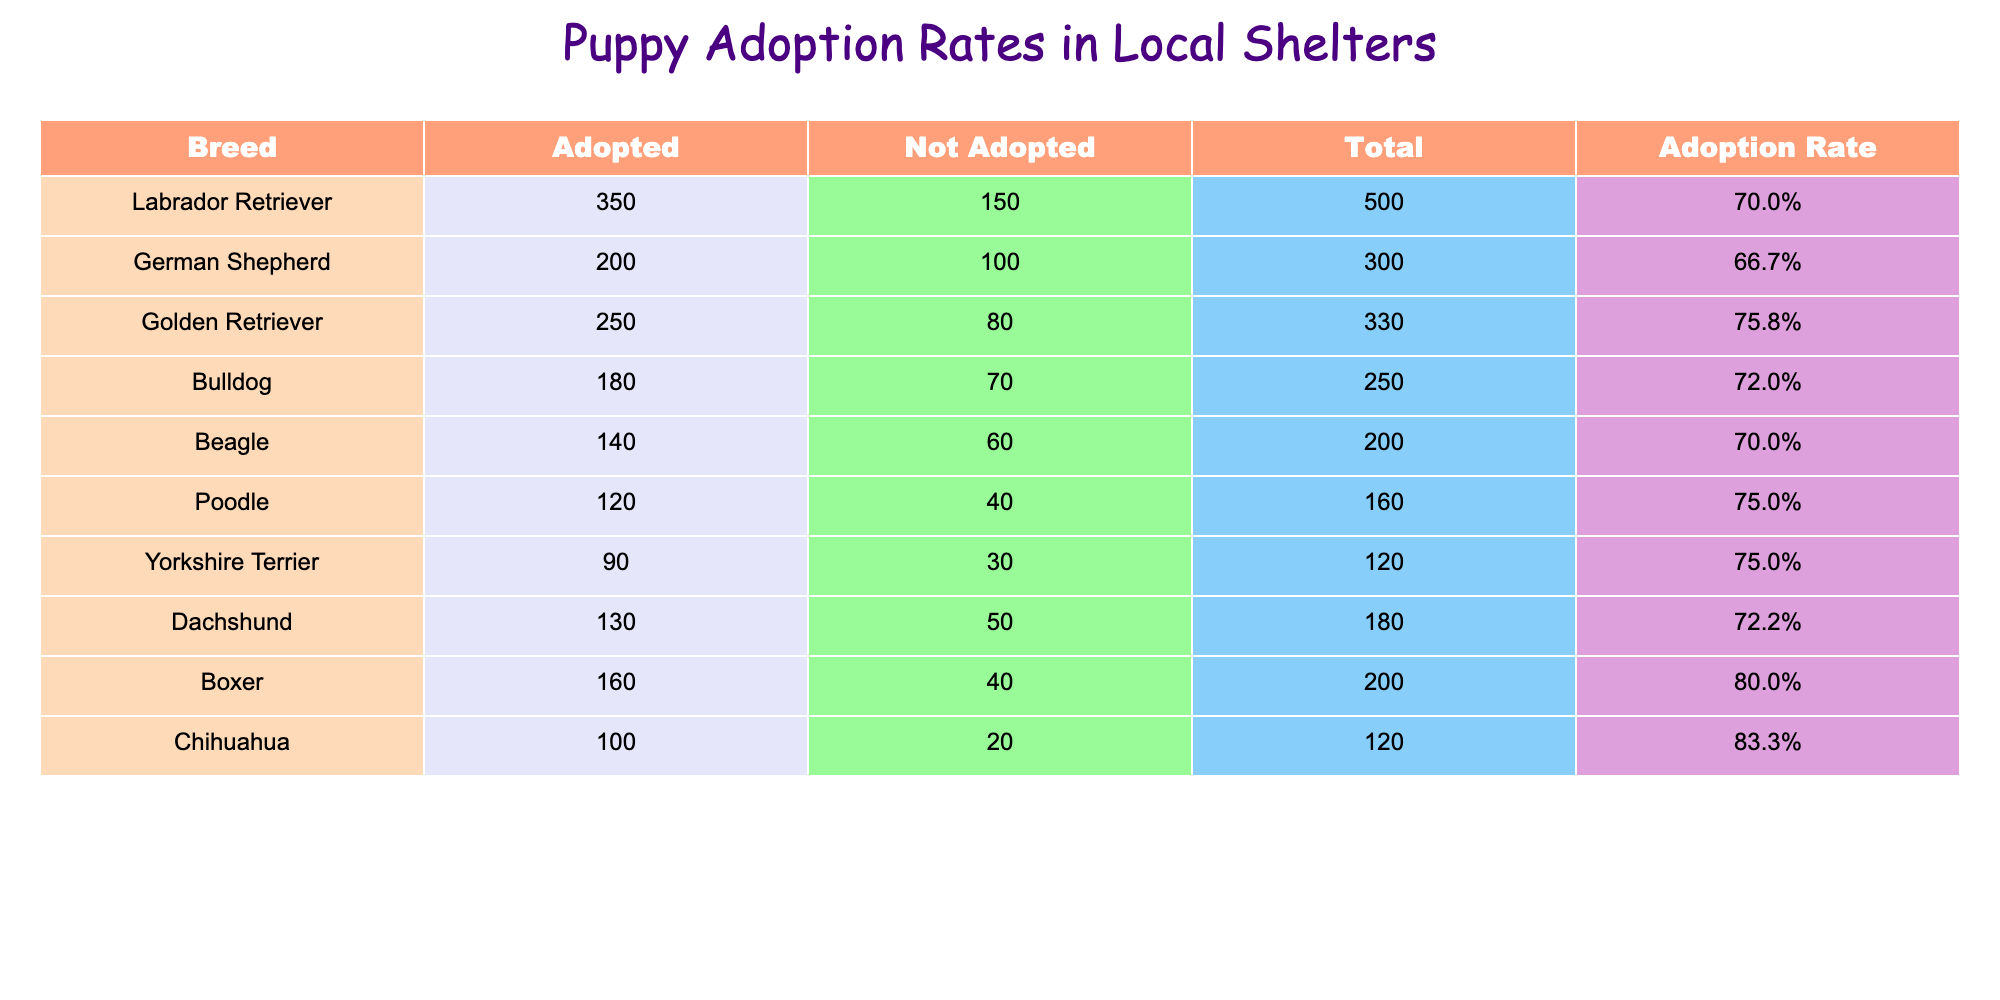What is the adoption rate for Labrador Retrievers? The adoption rate for Labrador Retrievers is presented in the table. It shows the value in the 'Adoption Rate' column corresponding to the 'Labrador Retriever' row, which is 70.0%.
Answer: 70.0% Which breed had the highest not adopted count? To find the breed with the highest not adopted count, we look at the 'Not Adopted' column and identify the largest value. The Bulldog has a count of 70.
Answer: Bulldog What is the average adoption rate for all breeds listed? First, we need to sum the adoption rates of all breeds: 70.0 + 66.7 + 75.8 + 72.0 + 70.0 + 75.0 + 75.0 + 72.2 + 80.0 + 83.3 =  60.8 for a total of 10 breeds. Then, we divide that total by 10. The average adoption rate is 73.08%.
Answer: 73.08% Did more Beagles get adopted than Dachshunds? To answer this, we compare the 'Adopted' counts for Beagles and Dachshunds. Beagles have 140 adopted, while Dachshunds have 130. Since 140 > 130, the answer is yes.
Answer: Yes What is the total number of puppies adopted across all breeds? We can find this by summing the 'Adopted' column: 350 + 200 + 250 + 180 + 140 + 120 + 90 + 130 + 160 + 100 = 1,720. Thus, the total number of puppies adopted is 1,720.
Answer: 1,720 Which breed has the lowest adoption rate, and what is that rate? To find the lowest adoption rate, we compare all rates in the 'Adoption Rate' column. The German Shepherd has the lowest rate of 66.7%.
Answer: German Shepherd, 66.7% How many total puppies were not adopted for Golden Retrievers and Boxers combined? We need to add the 'Not Adopted' counts for these two breeds: Golden Retrievers with 80 and Boxers with 40 gives a total of 120 not adopted puppies (80 + 40 = 120).
Answer: 120 Is the adoption rate for Chihuahuas the highest among the listed breeds? We will compare the adoption rate for Chihuahuas (83.3%) with others to verify if it's the highest. The next highest is Boxers with 80.0%, which confirms that Chihuahuas have the highest adoption rate.
Answer: Yes 